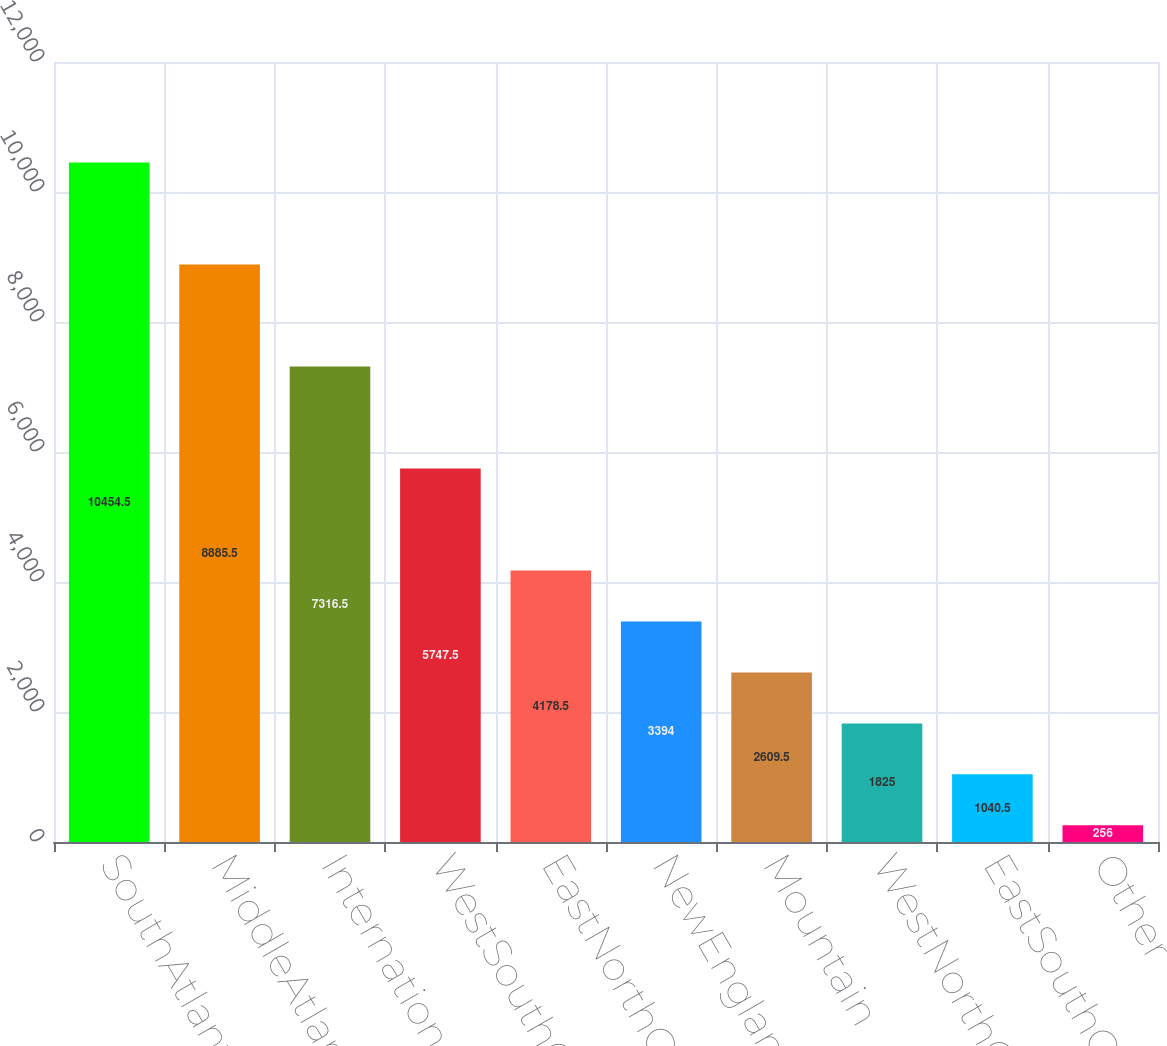Convert chart. <chart><loc_0><loc_0><loc_500><loc_500><bar_chart><fcel>SouthAtlantic<fcel>MiddleAtlantic<fcel>International<fcel>WestSouthCentral<fcel>EastNorthCentral<fcel>NewEngland<fcel>Mountain<fcel>WestNorthCentral<fcel>EastSouthCentral<fcel>Other<nl><fcel>10454.5<fcel>8885.5<fcel>7316.5<fcel>5747.5<fcel>4178.5<fcel>3394<fcel>2609.5<fcel>1825<fcel>1040.5<fcel>256<nl></chart> 